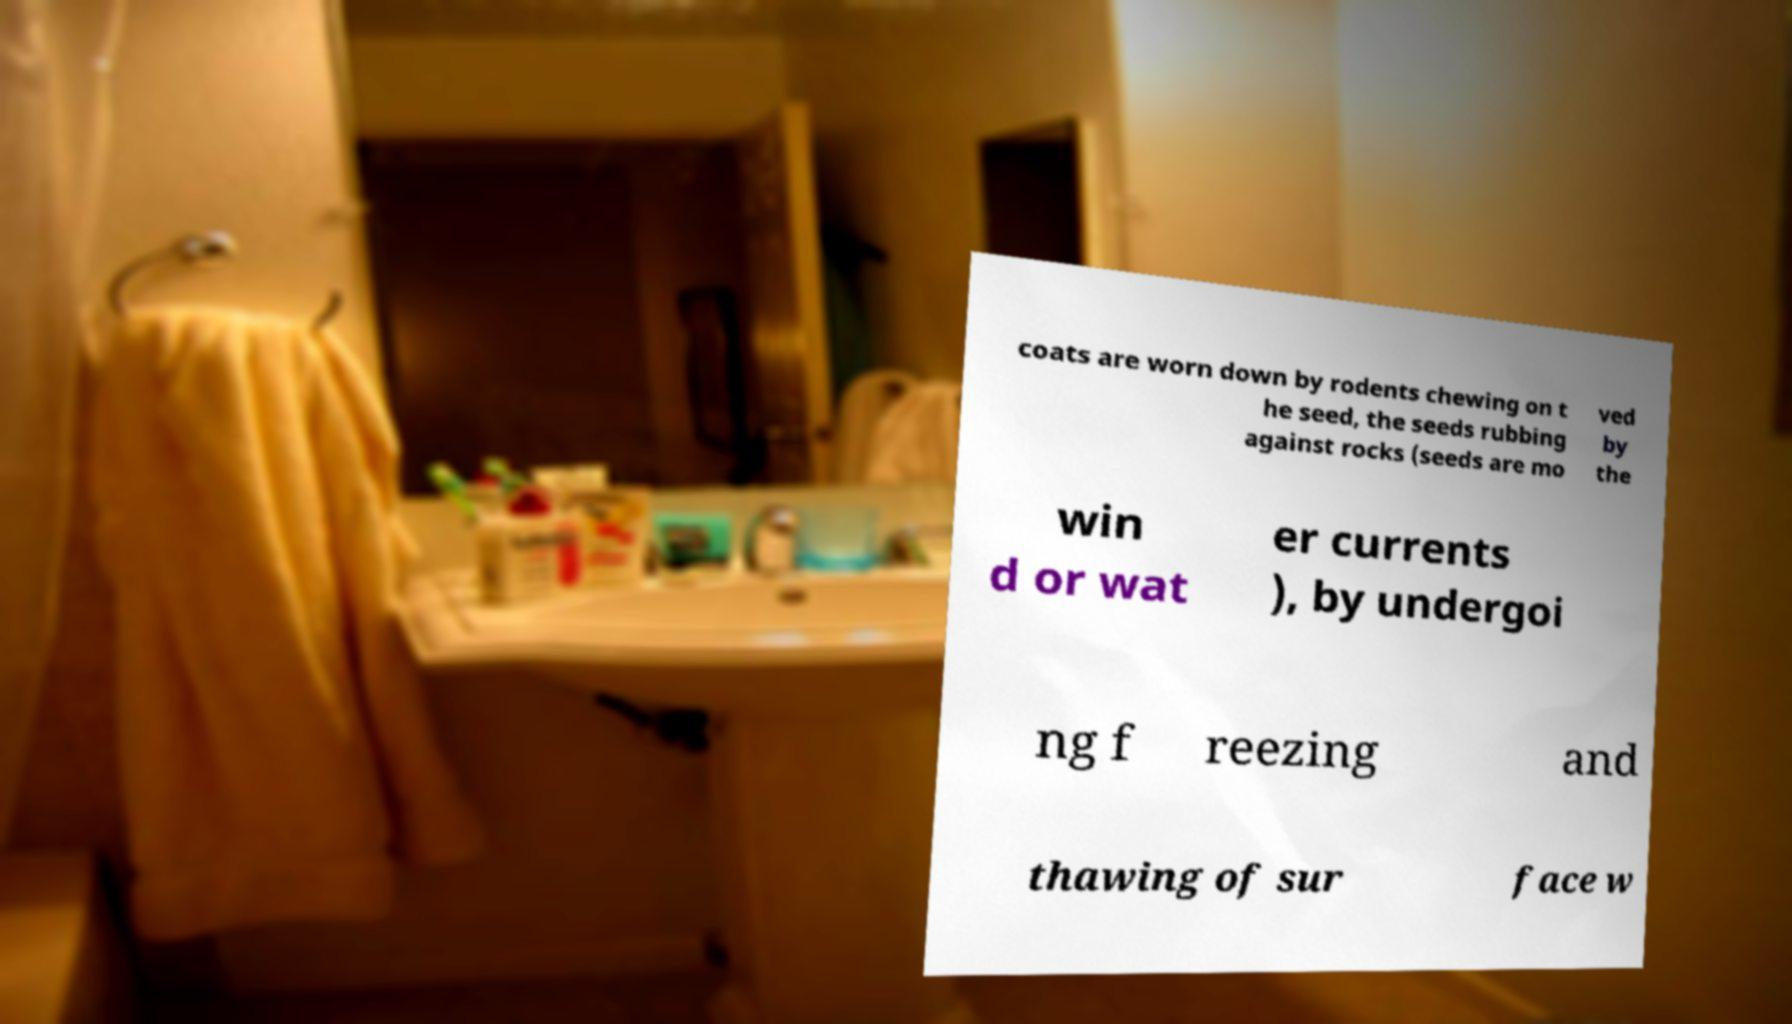What messages or text are displayed in this image? I need them in a readable, typed format. coats are worn down by rodents chewing on t he seed, the seeds rubbing against rocks (seeds are mo ved by the win d or wat er currents ), by undergoi ng f reezing and thawing of sur face w 